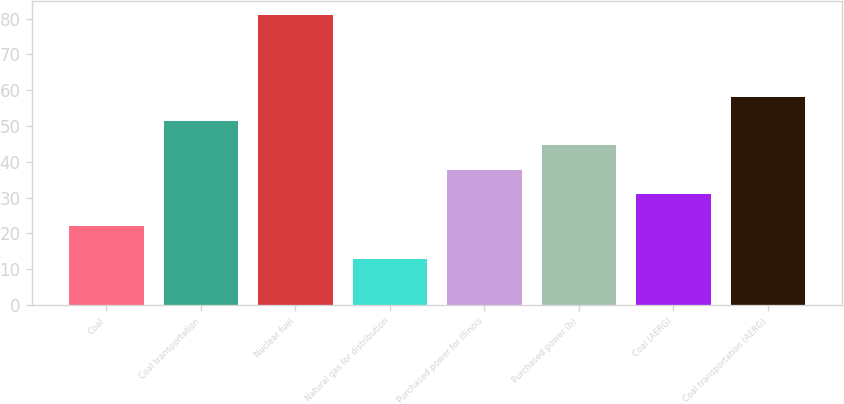<chart> <loc_0><loc_0><loc_500><loc_500><bar_chart><fcel>Coal<fcel>Coal transportation<fcel>Nuclear fuel<fcel>Natural gas for distribution<fcel>Purchased power for Illinois<fcel>Purchased power (b)<fcel>Coal (AERG)<fcel>Coal transportation (AERG)<nl><fcel>22<fcel>51.4<fcel>81<fcel>13<fcel>37.8<fcel>44.6<fcel>31<fcel>58.2<nl></chart> 